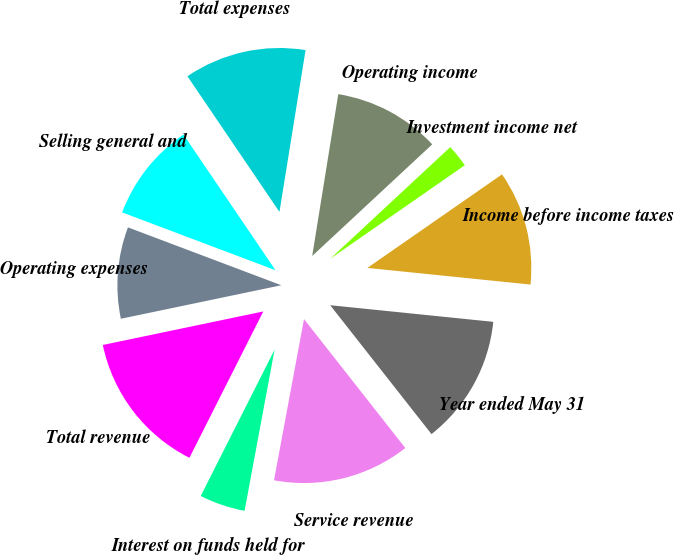Convert chart. <chart><loc_0><loc_0><loc_500><loc_500><pie_chart><fcel>Year ended May 31<fcel>Service revenue<fcel>Interest on funds held for<fcel>Total revenue<fcel>Operating expenses<fcel>Selling general and<fcel>Total expenses<fcel>Operating income<fcel>Investment income net<fcel>Income before income taxes<nl><fcel>12.78%<fcel>13.53%<fcel>4.51%<fcel>14.28%<fcel>9.02%<fcel>9.77%<fcel>12.03%<fcel>10.53%<fcel>2.26%<fcel>11.28%<nl></chart> 